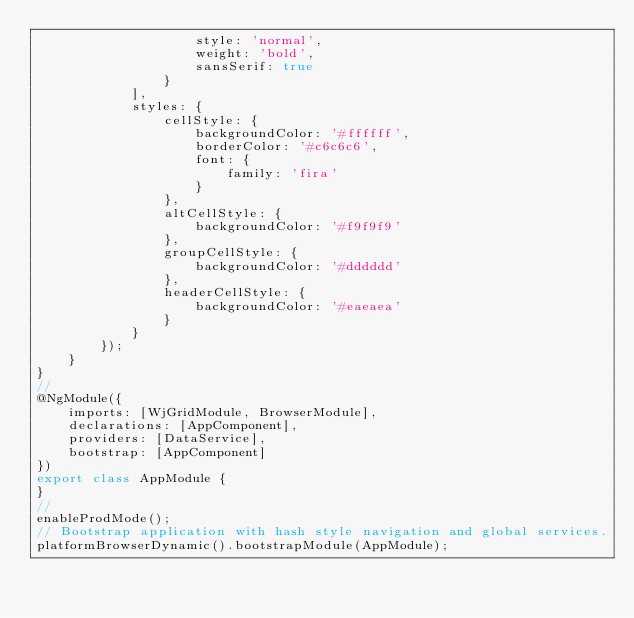Convert code to text. <code><loc_0><loc_0><loc_500><loc_500><_TypeScript_>                    style: 'normal',
                    weight: 'bold',
                    sansSerif: true
                }
            ],
            styles: {
                cellStyle: {
                    backgroundColor: '#ffffff',
                    borderColor: '#c6c6c6',
                    font: {
                        family: 'fira'
                    }
                },
                altCellStyle: {
                    backgroundColor: '#f9f9f9'
                },
                groupCellStyle: {
                    backgroundColor: '#dddddd'
                },
                headerCellStyle: {
                    backgroundColor: '#eaeaea'
                }
            }
        });
    }
}
//
@NgModule({
    imports: [WjGridModule, BrowserModule],
    declarations: [AppComponent],
    providers: [DataService],
    bootstrap: [AppComponent]
})
export class AppModule {
}
//
enableProdMode();
// Bootstrap application with hash style navigation and global services.
platformBrowserDynamic().bootstrapModule(AppModule);</code> 